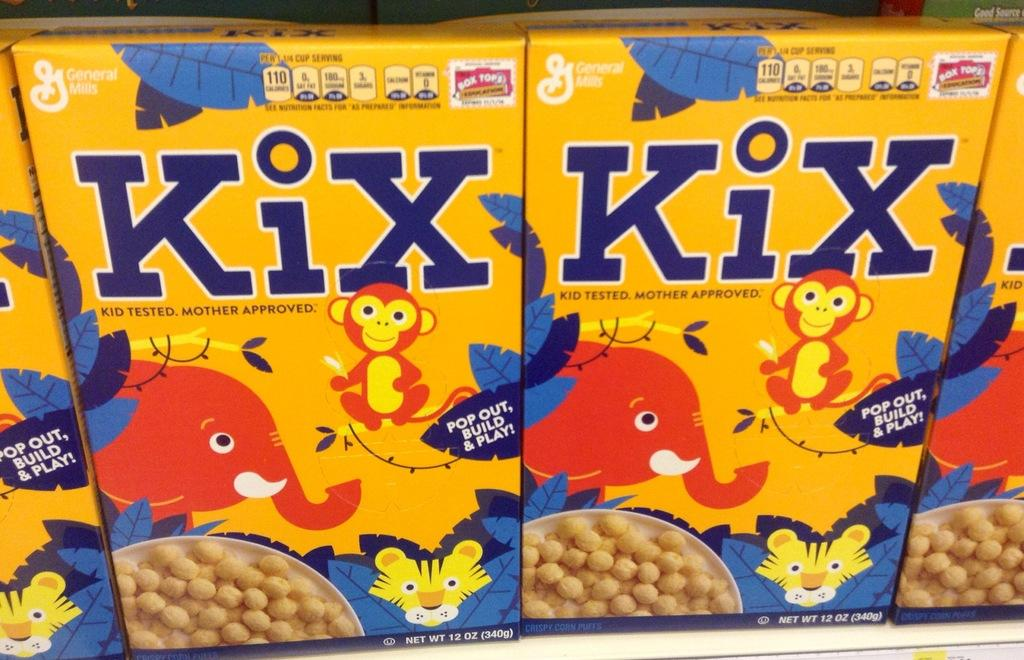What color are the food boxes in the image? The food boxes in the image are yellow. What is written on the food boxes? There is text on the yellow color food boxes. How many loaves of bread are on the food boxes in the image? There is no loaf of bread present on the food boxes in the image. What type of books can be seen on the food boxes in the image? There are no books present on the food boxes in the image. 